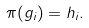Convert formula to latex. <formula><loc_0><loc_0><loc_500><loc_500>\pi ( g _ { i } ) = h _ { i } .</formula> 